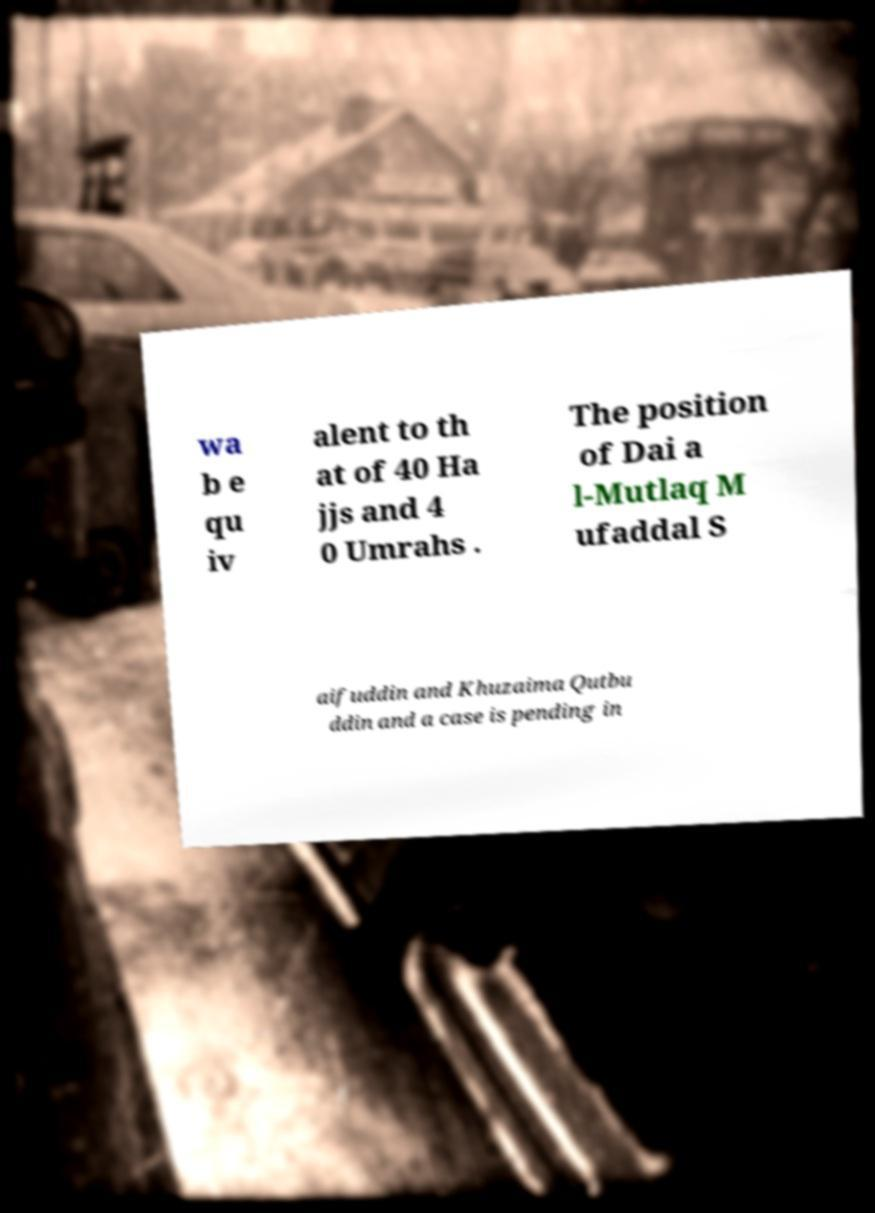Can you read and provide the text displayed in the image?This photo seems to have some interesting text. Can you extract and type it out for me? wa b e qu iv alent to th at of 40 Ha jjs and 4 0 Umrahs . The position of Dai a l-Mutlaq M ufaddal S aifuddin and Khuzaima Qutbu ddin and a case is pending in 